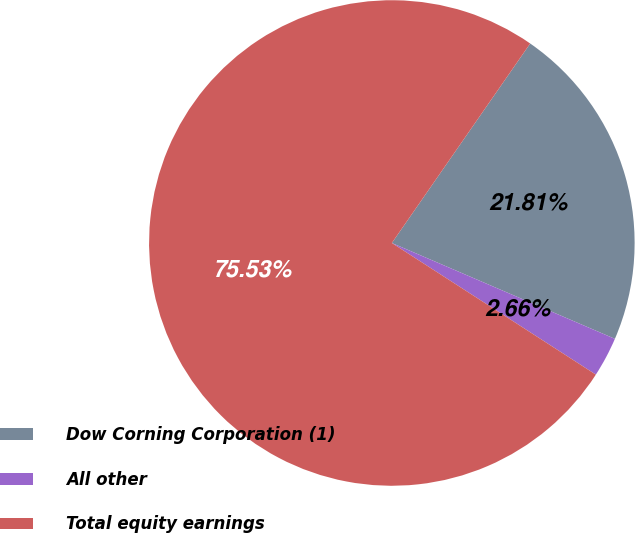Convert chart to OTSL. <chart><loc_0><loc_0><loc_500><loc_500><pie_chart><fcel>Dow Corning Corporation (1)<fcel>All other<fcel>Total equity earnings<nl><fcel>21.81%<fcel>2.66%<fcel>75.53%<nl></chart> 